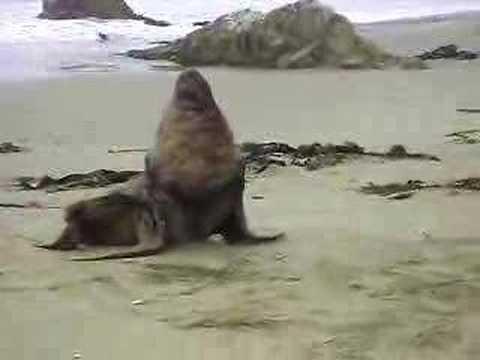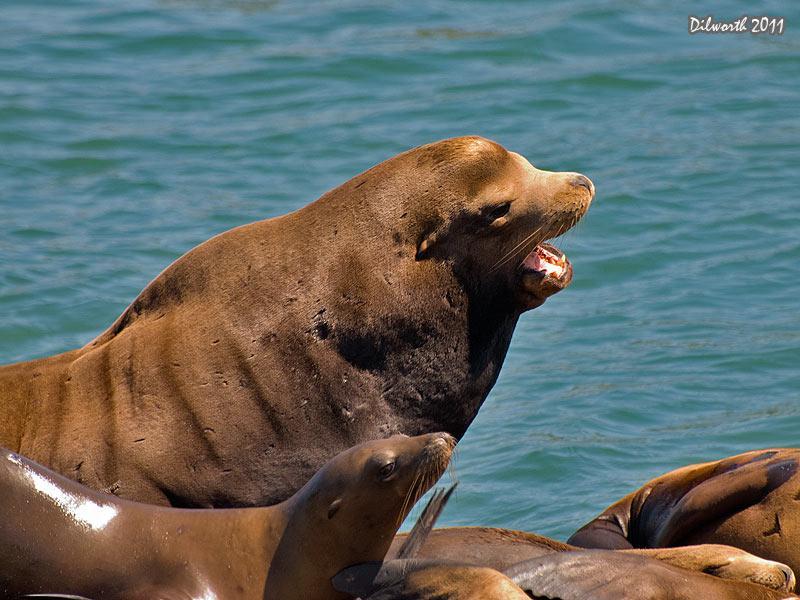The first image is the image on the left, the second image is the image on the right. Assess this claim about the two images: "One of the sea lions in on sand.". Correct or not? Answer yes or no. Yes. The first image is the image on the left, the second image is the image on the right. Considering the images on both sides, is "One of the images is of a lone animal on a sandy beach." valid? Answer yes or no. Yes. 